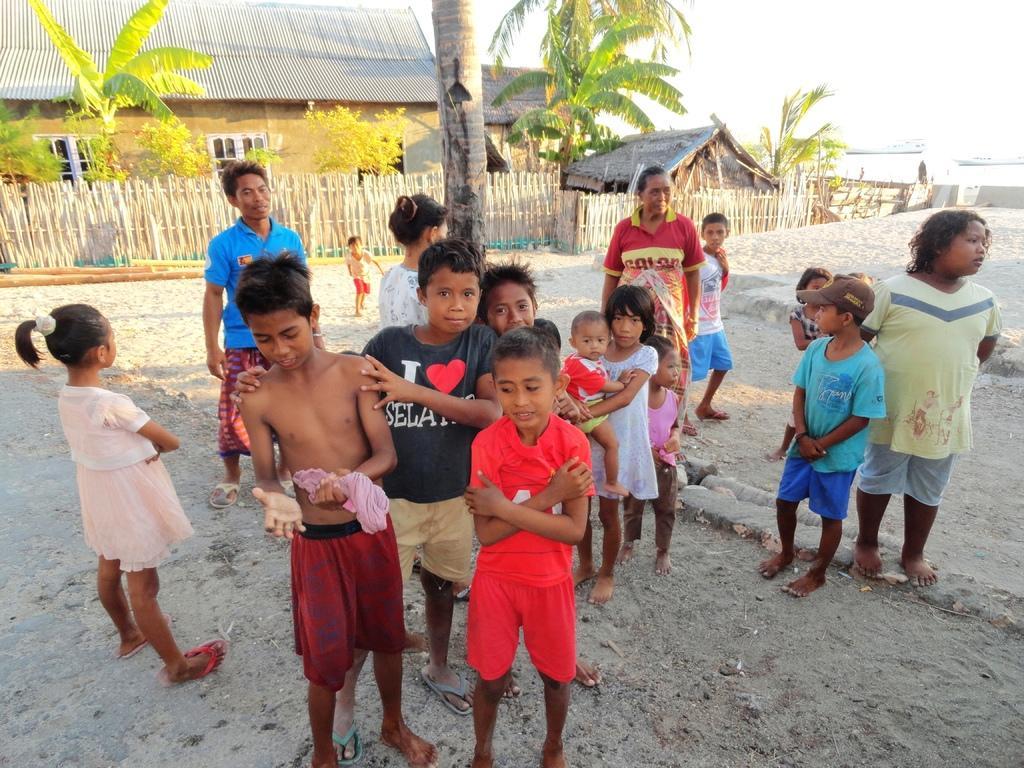Describe this image in one or two sentences. In the image there are few people standing on the ground in the foreground and behind them there is a tree, fencing, behind the fencing there are houses and trees, on the right side there is a water surface. 